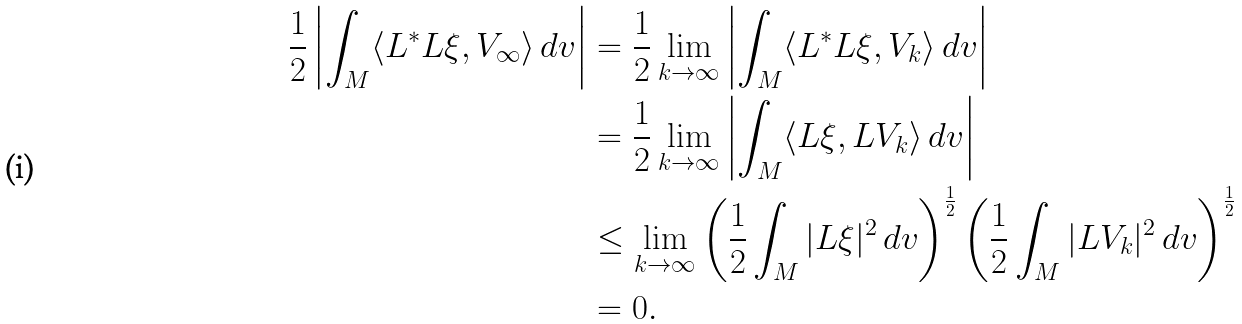Convert formula to latex. <formula><loc_0><loc_0><loc_500><loc_500>\frac { 1 } { 2 } \left | \int _ { M } \langle L ^ { * } L \xi , V _ { \infty } \rangle \, d v \right | & = \frac { 1 } { 2 } \lim _ { k \to \infty } \left | \int _ { M } \langle L ^ { * } L \xi , V _ { k } \rangle \, d v \right | \\ & = \frac { 1 } { 2 } \lim _ { k \to \infty } \left | \int _ { M } \langle L \xi , L V _ { k } \rangle \, d v \right | \\ & \leq \lim _ { k \to \infty } \left ( \frac { 1 } { 2 } \int _ { M } | L \xi | ^ { 2 } \, d v \right ) ^ { \frac { 1 } { 2 } } \left ( \frac { 1 } { 2 } \int _ { M } | L V _ { k } | ^ { 2 } \, d v \right ) ^ { \frac { 1 } { 2 } } \\ & = 0 .</formula> 